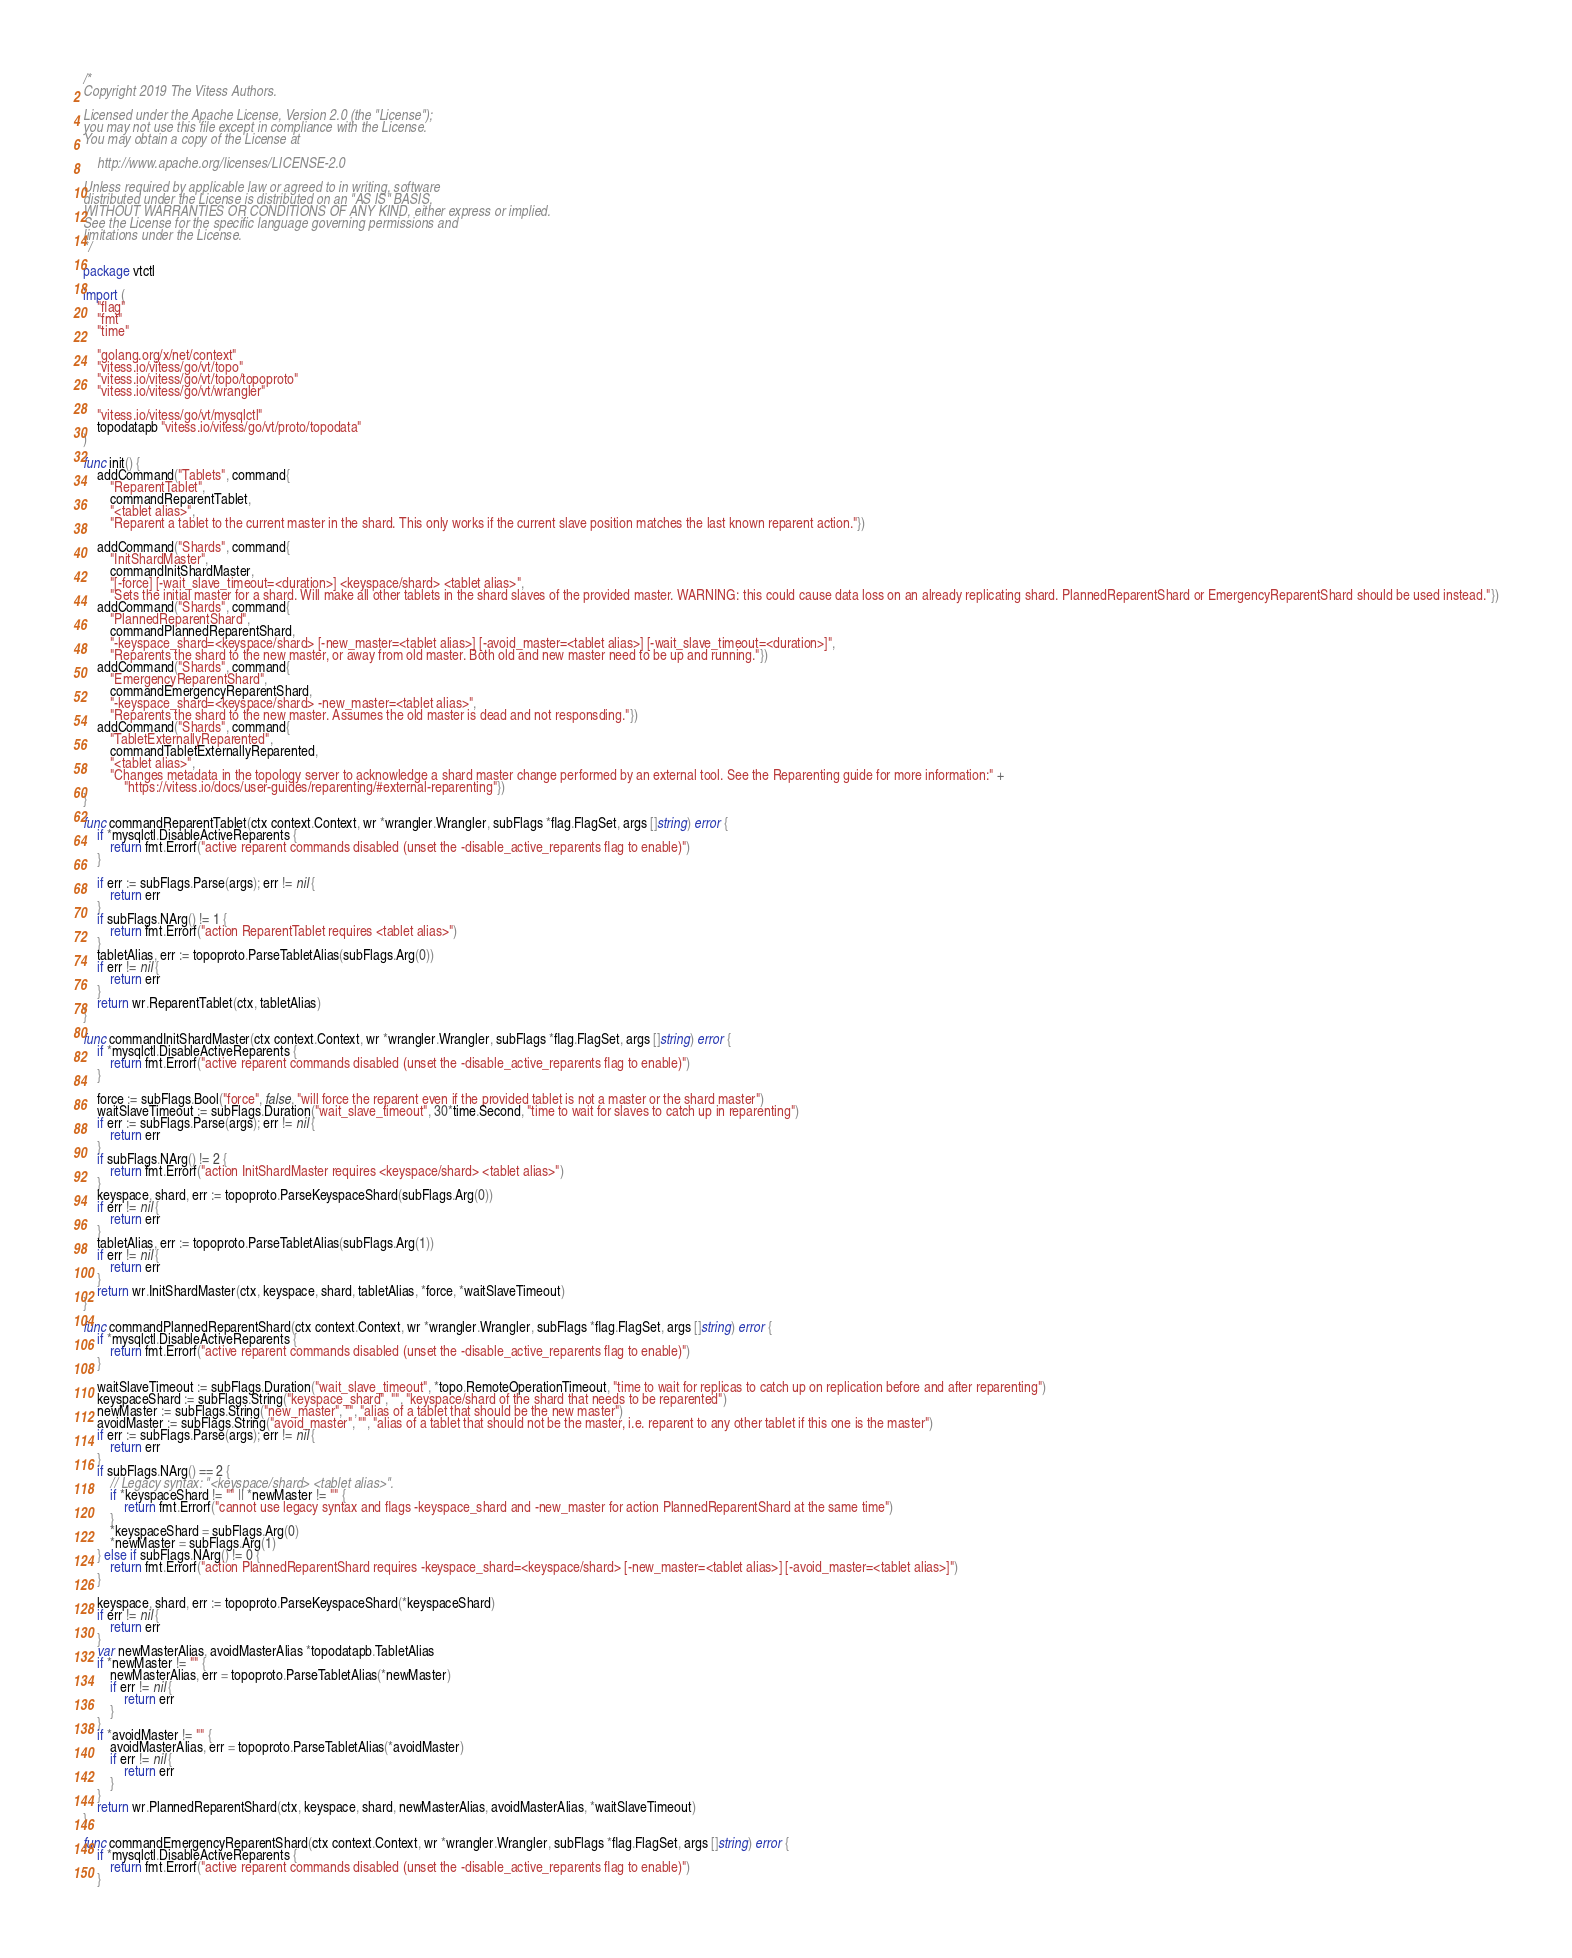Convert code to text. <code><loc_0><loc_0><loc_500><loc_500><_Go_>/*
Copyright 2019 The Vitess Authors.

Licensed under the Apache License, Version 2.0 (the "License");
you may not use this file except in compliance with the License.
You may obtain a copy of the License at

    http://www.apache.org/licenses/LICENSE-2.0

Unless required by applicable law or agreed to in writing, software
distributed under the License is distributed on an "AS IS" BASIS,
WITHOUT WARRANTIES OR CONDITIONS OF ANY KIND, either express or implied.
See the License for the specific language governing permissions and
limitations under the License.
*/

package vtctl

import (
	"flag"
	"fmt"
	"time"

	"golang.org/x/net/context"
	"vitess.io/vitess/go/vt/topo"
	"vitess.io/vitess/go/vt/topo/topoproto"
	"vitess.io/vitess/go/vt/wrangler"

	"vitess.io/vitess/go/vt/mysqlctl"
	topodatapb "vitess.io/vitess/go/vt/proto/topodata"
)

func init() {
	addCommand("Tablets", command{
		"ReparentTablet",
		commandReparentTablet,
		"<tablet alias>",
		"Reparent a tablet to the current master in the shard. This only works if the current slave position matches the last known reparent action."})

	addCommand("Shards", command{
		"InitShardMaster",
		commandInitShardMaster,
		"[-force] [-wait_slave_timeout=<duration>] <keyspace/shard> <tablet alias>",
		"Sets the initial master for a shard. Will make all other tablets in the shard slaves of the provided master. WARNING: this could cause data loss on an already replicating shard. PlannedReparentShard or EmergencyReparentShard should be used instead."})
	addCommand("Shards", command{
		"PlannedReparentShard",
		commandPlannedReparentShard,
		"-keyspace_shard=<keyspace/shard> [-new_master=<tablet alias>] [-avoid_master=<tablet alias>] [-wait_slave_timeout=<duration>]",
		"Reparents the shard to the new master, or away from old master. Both old and new master need to be up and running."})
	addCommand("Shards", command{
		"EmergencyReparentShard",
		commandEmergencyReparentShard,
		"-keyspace_shard=<keyspace/shard> -new_master=<tablet alias>",
		"Reparents the shard to the new master. Assumes the old master is dead and not responsding."})
	addCommand("Shards", command{
		"TabletExternallyReparented",
		commandTabletExternallyReparented,
		"<tablet alias>",
		"Changes metadata in the topology server to acknowledge a shard master change performed by an external tool. See the Reparenting guide for more information:" +
			"https://vitess.io/docs/user-guides/reparenting/#external-reparenting"})
}

func commandReparentTablet(ctx context.Context, wr *wrangler.Wrangler, subFlags *flag.FlagSet, args []string) error {
	if *mysqlctl.DisableActiveReparents {
		return fmt.Errorf("active reparent commands disabled (unset the -disable_active_reparents flag to enable)")
	}

	if err := subFlags.Parse(args); err != nil {
		return err
	}
	if subFlags.NArg() != 1 {
		return fmt.Errorf("action ReparentTablet requires <tablet alias>")
	}
	tabletAlias, err := topoproto.ParseTabletAlias(subFlags.Arg(0))
	if err != nil {
		return err
	}
	return wr.ReparentTablet(ctx, tabletAlias)
}

func commandInitShardMaster(ctx context.Context, wr *wrangler.Wrangler, subFlags *flag.FlagSet, args []string) error {
	if *mysqlctl.DisableActiveReparents {
		return fmt.Errorf("active reparent commands disabled (unset the -disable_active_reparents flag to enable)")
	}

	force := subFlags.Bool("force", false, "will force the reparent even if the provided tablet is not a master or the shard master")
	waitSlaveTimeout := subFlags.Duration("wait_slave_timeout", 30*time.Second, "time to wait for slaves to catch up in reparenting")
	if err := subFlags.Parse(args); err != nil {
		return err
	}
	if subFlags.NArg() != 2 {
		return fmt.Errorf("action InitShardMaster requires <keyspace/shard> <tablet alias>")
	}
	keyspace, shard, err := topoproto.ParseKeyspaceShard(subFlags.Arg(0))
	if err != nil {
		return err
	}
	tabletAlias, err := topoproto.ParseTabletAlias(subFlags.Arg(1))
	if err != nil {
		return err
	}
	return wr.InitShardMaster(ctx, keyspace, shard, tabletAlias, *force, *waitSlaveTimeout)
}

func commandPlannedReparentShard(ctx context.Context, wr *wrangler.Wrangler, subFlags *flag.FlagSet, args []string) error {
	if *mysqlctl.DisableActiveReparents {
		return fmt.Errorf("active reparent commands disabled (unset the -disable_active_reparents flag to enable)")
	}

	waitSlaveTimeout := subFlags.Duration("wait_slave_timeout", *topo.RemoteOperationTimeout, "time to wait for replicas to catch up on replication before and after reparenting")
	keyspaceShard := subFlags.String("keyspace_shard", "", "keyspace/shard of the shard that needs to be reparented")
	newMaster := subFlags.String("new_master", "", "alias of a tablet that should be the new master")
	avoidMaster := subFlags.String("avoid_master", "", "alias of a tablet that should not be the master, i.e. reparent to any other tablet if this one is the master")
	if err := subFlags.Parse(args); err != nil {
		return err
	}
	if subFlags.NArg() == 2 {
		// Legacy syntax: "<keyspace/shard> <tablet alias>".
		if *keyspaceShard != "" || *newMaster != "" {
			return fmt.Errorf("cannot use legacy syntax and flags -keyspace_shard and -new_master for action PlannedReparentShard at the same time")
		}
		*keyspaceShard = subFlags.Arg(0)
		*newMaster = subFlags.Arg(1)
	} else if subFlags.NArg() != 0 {
		return fmt.Errorf("action PlannedReparentShard requires -keyspace_shard=<keyspace/shard> [-new_master=<tablet alias>] [-avoid_master=<tablet alias>]")
	}

	keyspace, shard, err := topoproto.ParseKeyspaceShard(*keyspaceShard)
	if err != nil {
		return err
	}
	var newMasterAlias, avoidMasterAlias *topodatapb.TabletAlias
	if *newMaster != "" {
		newMasterAlias, err = topoproto.ParseTabletAlias(*newMaster)
		if err != nil {
			return err
		}
	}
	if *avoidMaster != "" {
		avoidMasterAlias, err = topoproto.ParseTabletAlias(*avoidMaster)
		if err != nil {
			return err
		}
	}
	return wr.PlannedReparentShard(ctx, keyspace, shard, newMasterAlias, avoidMasterAlias, *waitSlaveTimeout)
}

func commandEmergencyReparentShard(ctx context.Context, wr *wrangler.Wrangler, subFlags *flag.FlagSet, args []string) error {
	if *mysqlctl.DisableActiveReparents {
		return fmt.Errorf("active reparent commands disabled (unset the -disable_active_reparents flag to enable)")
	}
</code> 